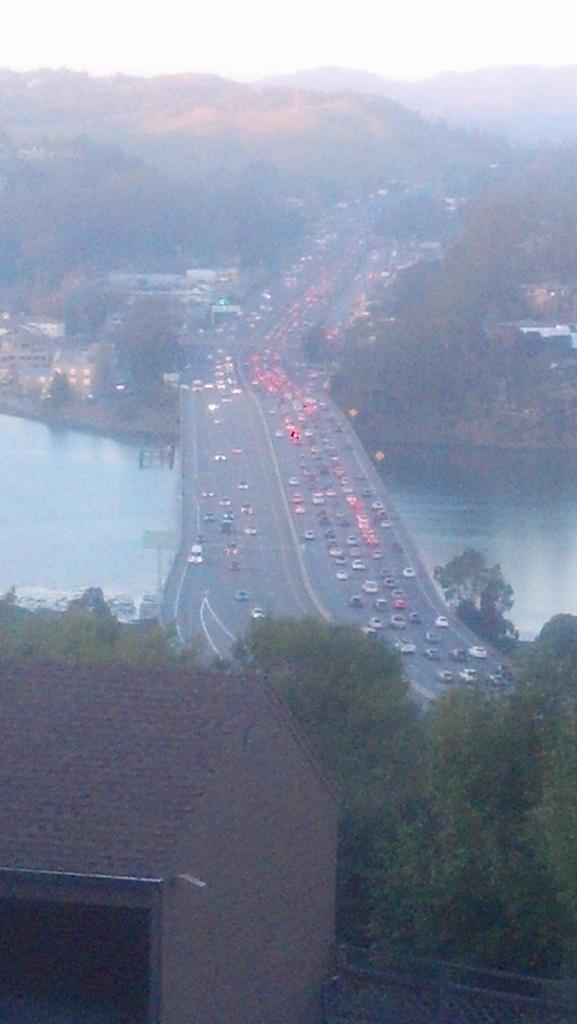Please provide a concise description of this image. This is an outside view. At the bottom there is a house and trees. In the middle of the image there are many vehicles on a bridge. Under the bridge there is a sea. In the background there are many buildings, trees and hills. At the top of the image I can see the sky. 